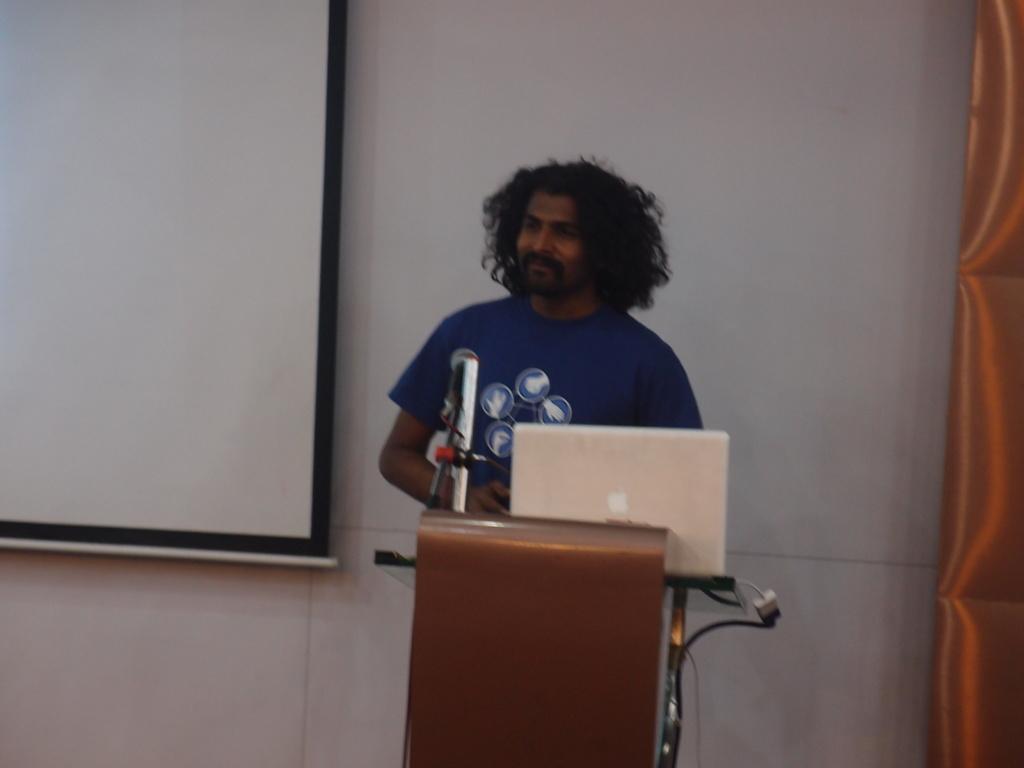In one or two sentences, can you explain what this image depicts? Here we can see a man standing in front of a mike. There is a podium and a laptop. In the background we can see wall and a screen. 